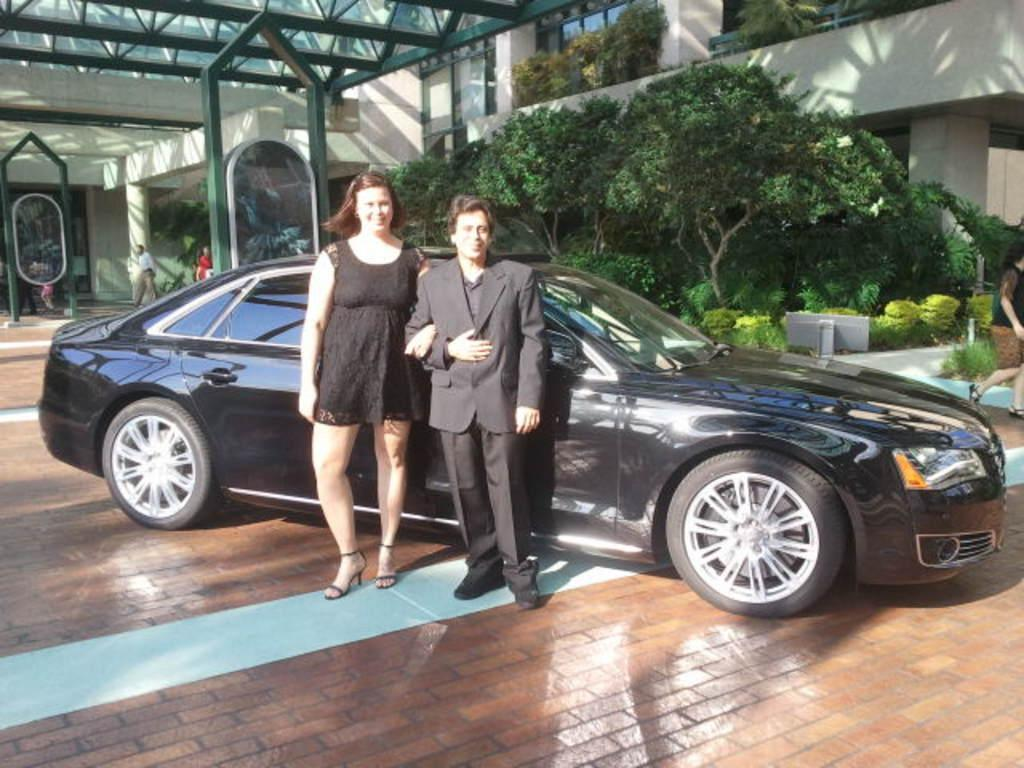How many people are present in the image? There are two people, a man and a woman, present in the image. What are the man and woman doing in the image? The man and woman are standing beside a car in the image. What type of vegetation can be seen in the image? There are plants and trees visible in the image. What architectural features can be seen in the image? There are pillars visible in the image. What is visible in the background of the image? There is a building in the background of the image. What type of question is the donkey asking in the image? There is no donkey present in the image, and therefore no such activity can be observed. 